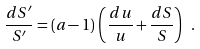<formula> <loc_0><loc_0><loc_500><loc_500>\frac { d S ^ { \prime } } { S ^ { \prime } } = ( a - 1 ) \, \left ( \frac { d u } { u } + \frac { d S } { S } \right ) \ .</formula> 